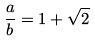Convert formula to latex. <formula><loc_0><loc_0><loc_500><loc_500>\frac { a } { b } = 1 + \sqrt { 2 }</formula> 